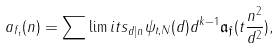<formula> <loc_0><loc_0><loc_500><loc_500>a _ { f _ { t } } ( n ) = \sum \lim i t s _ { d | n } \psi _ { t , N } ( d ) d ^ { k - 1 } \mathfrak { a } _ { \mathfrak { f } } ( t \frac { n ^ { 2 } } { d ^ { 2 } } ) ,</formula> 